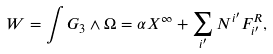<formula> <loc_0><loc_0><loc_500><loc_500>W = \int G _ { 3 } \wedge \Omega = \alpha X ^ { \infty } + \sum _ { i ^ { \prime } } N ^ { i ^ { \prime } } F ^ { R } _ { i ^ { \prime } } ,</formula> 